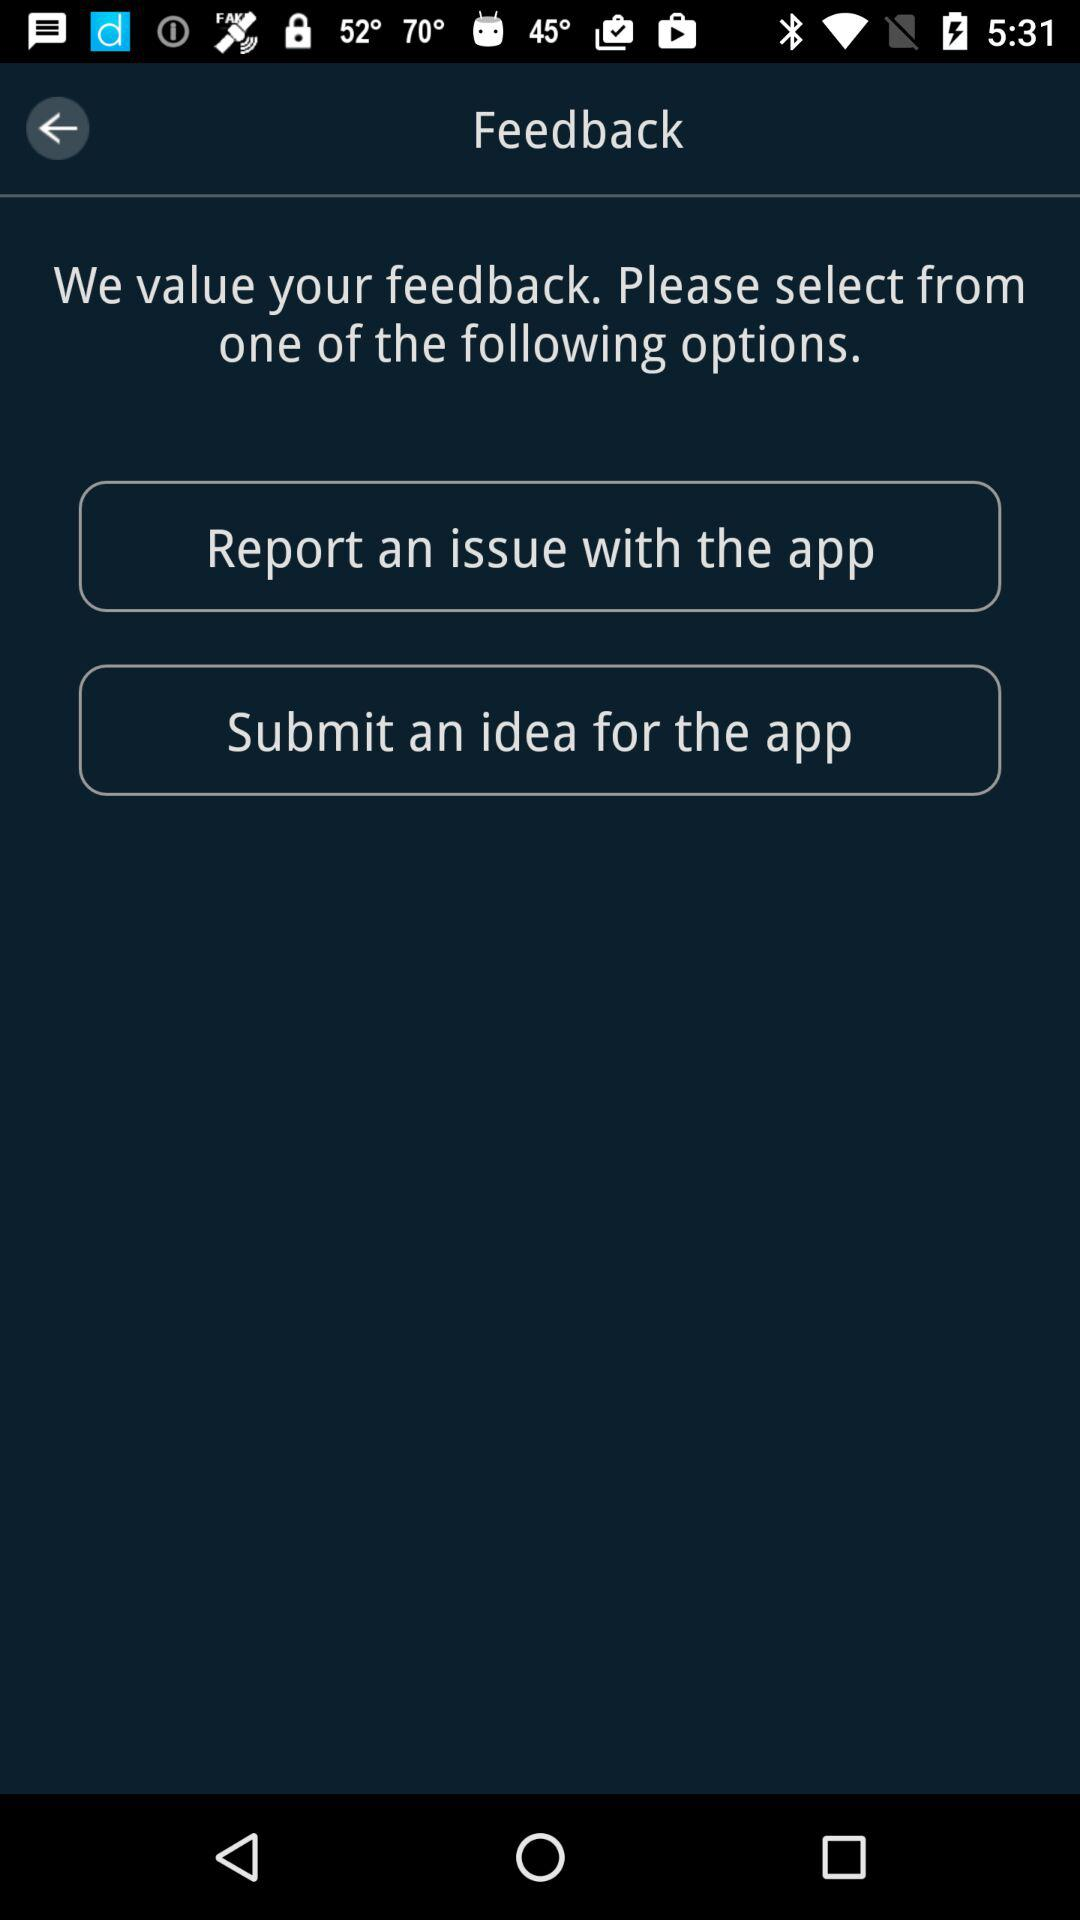How many more options are there for submitting feedback than there are for navigating the app?
Answer the question using a single word or phrase. 2 